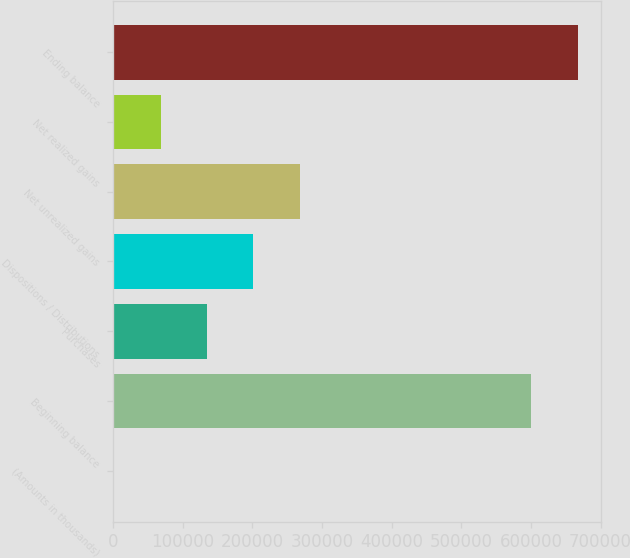Convert chart to OTSL. <chart><loc_0><loc_0><loc_500><loc_500><bar_chart><fcel>(Amounts in thousands)<fcel>Beginning balance<fcel>Purchases<fcel>Dispositions / Distributions<fcel>Net unrealized gains<fcel>Net realized gains<fcel>Ending balance<nl><fcel>2013<fcel>600786<fcel>135152<fcel>201722<fcel>268292<fcel>68582.7<fcel>667710<nl></chart> 